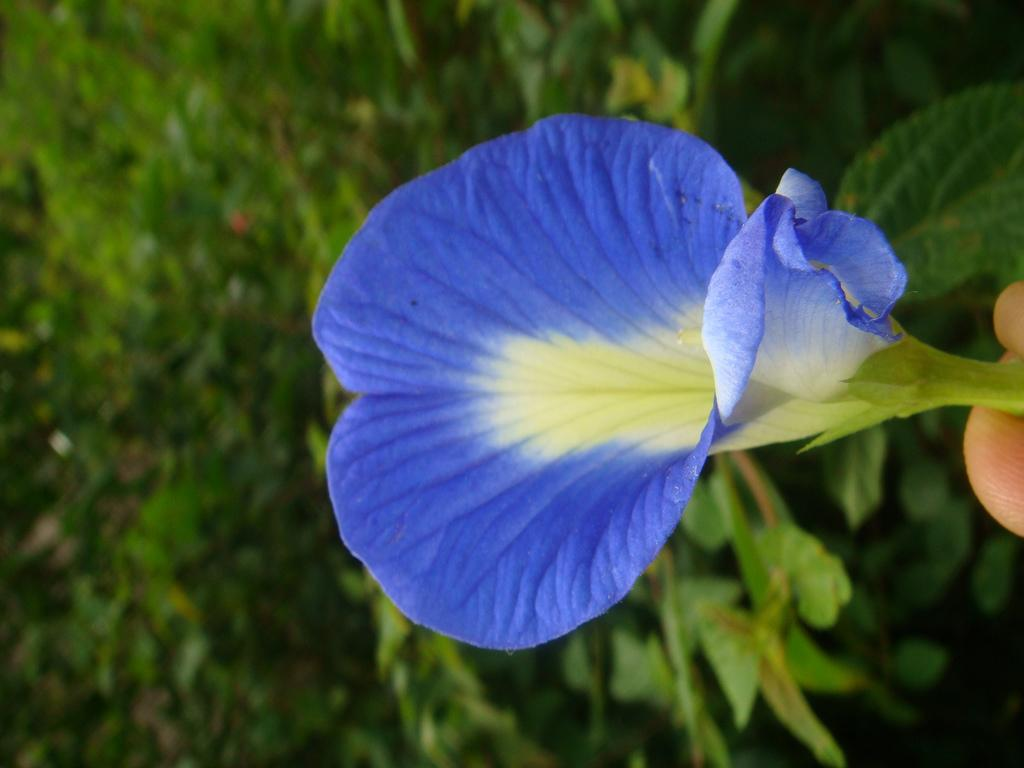What color is the flower in the image? The flower in the image is blue. What else can be seen in the image besides the flower? There are plants behind the flower in the image. What type of leather is used to make the apparel in the image? There is no apparel or leather present in the image; it only features a blue flower and plants. 